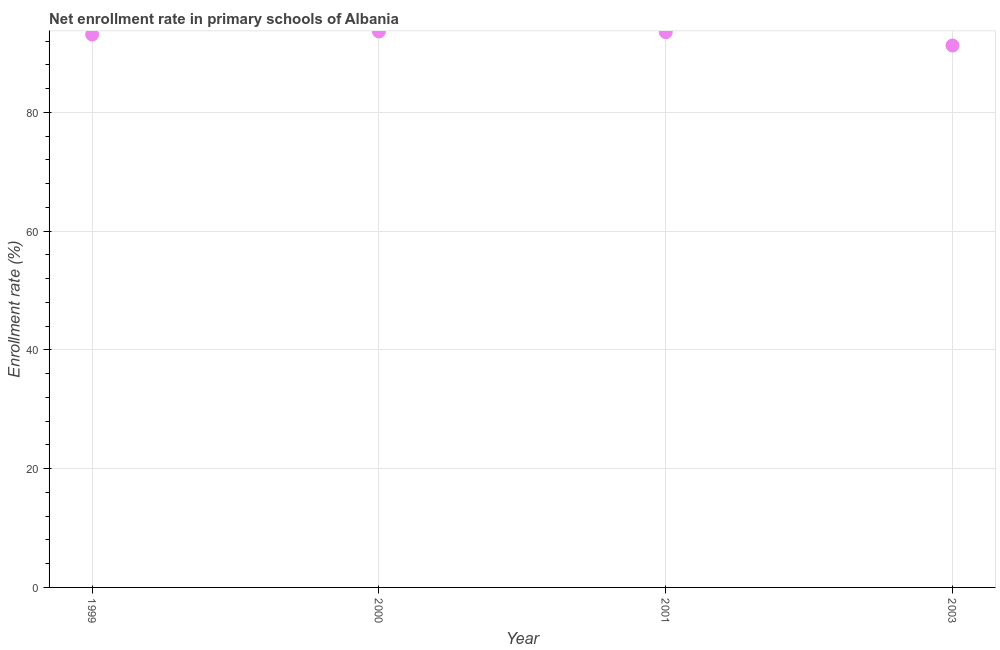What is the net enrollment rate in primary schools in 2001?
Offer a very short reply. 93.5. Across all years, what is the maximum net enrollment rate in primary schools?
Provide a succinct answer. 93.6. Across all years, what is the minimum net enrollment rate in primary schools?
Keep it short and to the point. 91.25. In which year was the net enrollment rate in primary schools maximum?
Your response must be concise. 2000. In which year was the net enrollment rate in primary schools minimum?
Your answer should be very brief. 2003. What is the sum of the net enrollment rate in primary schools?
Make the answer very short. 371.43. What is the difference between the net enrollment rate in primary schools in 2000 and 2003?
Offer a very short reply. 2.35. What is the average net enrollment rate in primary schools per year?
Offer a very short reply. 92.86. What is the median net enrollment rate in primary schools?
Give a very brief answer. 93.29. In how many years, is the net enrollment rate in primary schools greater than 16 %?
Offer a very short reply. 4. What is the ratio of the net enrollment rate in primary schools in 1999 to that in 2001?
Keep it short and to the point. 1. What is the difference between the highest and the second highest net enrollment rate in primary schools?
Keep it short and to the point. 0.11. Is the sum of the net enrollment rate in primary schools in 1999 and 2003 greater than the maximum net enrollment rate in primary schools across all years?
Give a very brief answer. Yes. What is the difference between the highest and the lowest net enrollment rate in primary schools?
Make the answer very short. 2.35. How many dotlines are there?
Offer a very short reply. 1. How many years are there in the graph?
Provide a short and direct response. 4. What is the difference between two consecutive major ticks on the Y-axis?
Provide a succinct answer. 20. What is the title of the graph?
Offer a terse response. Net enrollment rate in primary schools of Albania. What is the label or title of the Y-axis?
Make the answer very short. Enrollment rate (%). What is the Enrollment rate (%) in 1999?
Provide a succinct answer. 93.09. What is the Enrollment rate (%) in 2000?
Ensure brevity in your answer.  93.6. What is the Enrollment rate (%) in 2001?
Your answer should be compact. 93.5. What is the Enrollment rate (%) in 2003?
Give a very brief answer. 91.25. What is the difference between the Enrollment rate (%) in 1999 and 2000?
Provide a succinct answer. -0.52. What is the difference between the Enrollment rate (%) in 1999 and 2001?
Your response must be concise. -0.41. What is the difference between the Enrollment rate (%) in 1999 and 2003?
Your answer should be compact. 1.84. What is the difference between the Enrollment rate (%) in 2000 and 2001?
Make the answer very short. 0.11. What is the difference between the Enrollment rate (%) in 2000 and 2003?
Give a very brief answer. 2.35. What is the difference between the Enrollment rate (%) in 2001 and 2003?
Your answer should be very brief. 2.25. What is the ratio of the Enrollment rate (%) in 1999 to that in 2000?
Offer a terse response. 0.99. What is the ratio of the Enrollment rate (%) in 1999 to that in 2001?
Give a very brief answer. 1. What is the ratio of the Enrollment rate (%) in 2000 to that in 2003?
Ensure brevity in your answer.  1.03. 